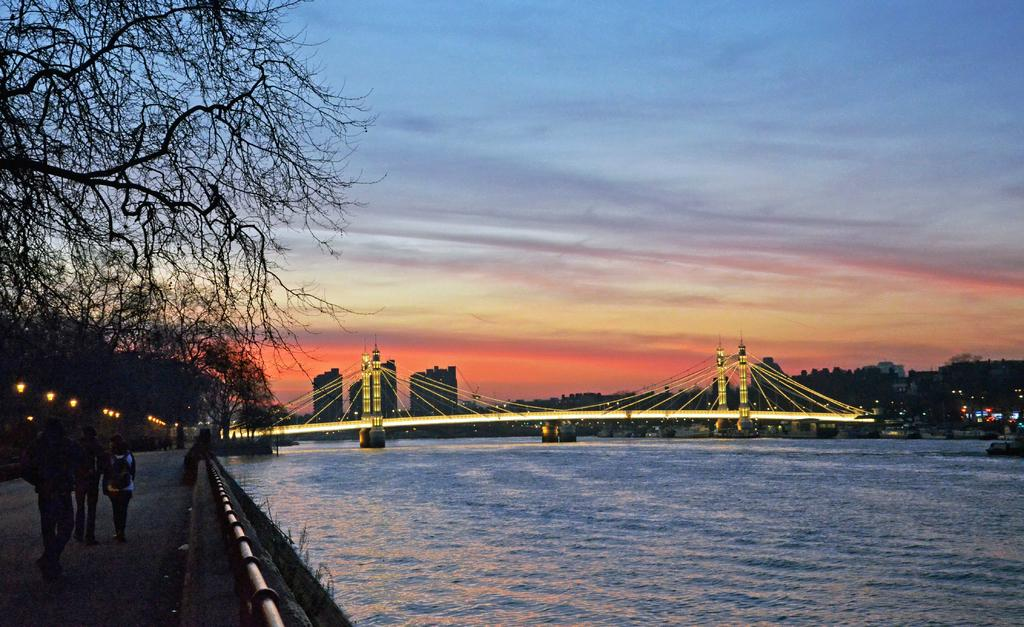How many people can be seen in the image? There are people in the image, but the exact number is not specified. Where are the people located in the image? The people are on the road in the image. What structure is present in the image that spans a body of water? There is a bridge with lights in the image. What type of natural feature is visible in the image? Water is visible in the image. What type of vegetation is present in the image? Trees are present in the image. What type of man-made structures can be seen in the image? Buildings are present in the image. What part of the natural environment is visible in the image? The sky is visible in the image. What type of weather can be inferred from the image? Clouds are present in the sky, suggesting that it might be a partly cloudy day. What type of cactus can be seen growing on the bridge in the image? There is no cactus present on the bridge in the image. What is the taste of the bread that the people are eating in the image? There is no bread visible in the image, so it cannot be determined if the people are eating bread or what its taste might be. 